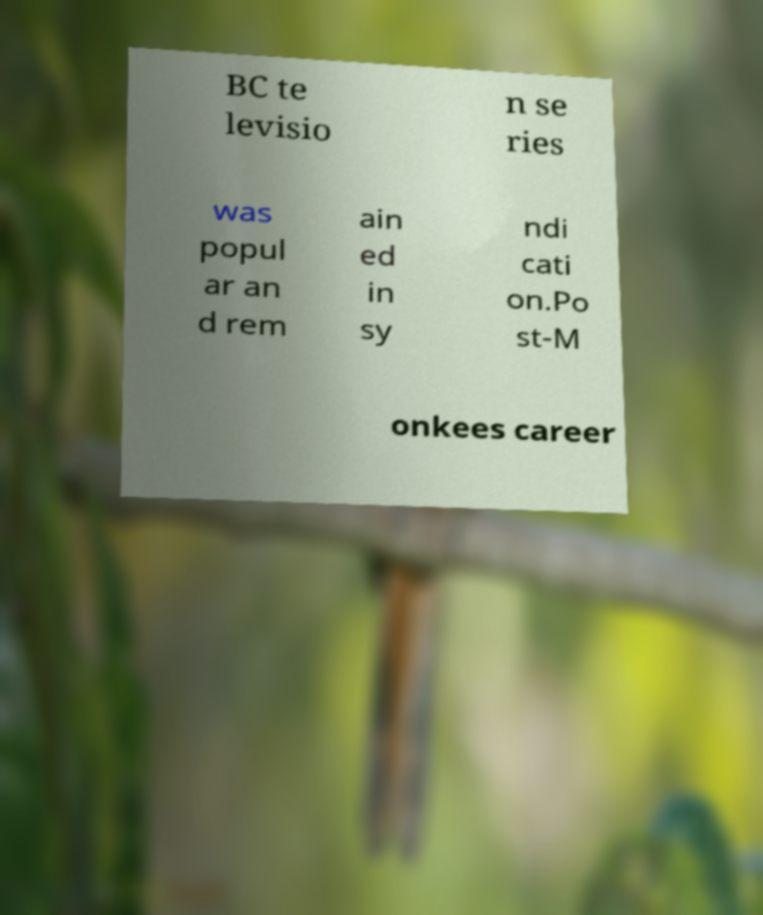Could you assist in decoding the text presented in this image and type it out clearly? BC te levisio n se ries was popul ar an d rem ain ed in sy ndi cati on.Po st-M onkees career 